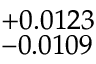Convert formula to latex. <formula><loc_0><loc_0><loc_500><loc_500>^ { + 0 . 0 1 2 3 } _ { - 0 . 0 1 0 9 }</formula> 